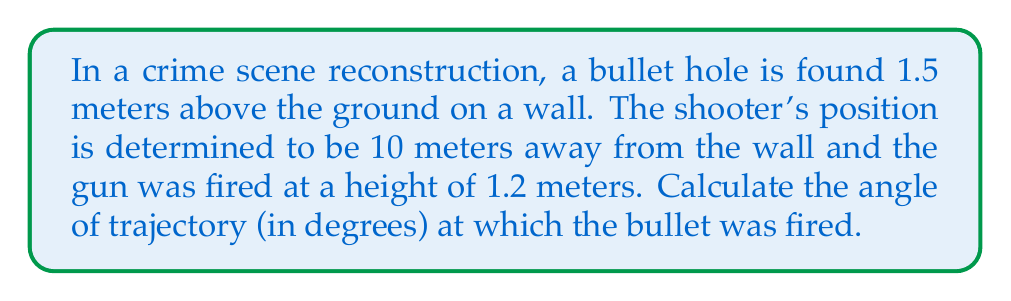What is the answer to this math problem? Let's approach this step-by-step:

1) First, we need to visualize the problem. We can think of this as a right triangle where:
   - The horizontal distance is 10 meters
   - The vertical distance is the difference between the bullet hole height and the gun height
   
2) Calculate the vertical distance:
   $1.5 \text{ m} - 1.2 \text{ m} = 0.3 \text{ m}$

3) Now we have a right triangle where:
   - The adjacent side (horizontal distance) is 10 meters
   - The opposite side (vertical distance) is 0.3 meters

4) To find the angle, we can use the tangent function:

   $$\tan(\theta) = \frac{\text{opposite}}{\text{adjacent}} = \frac{0.3}{10} = 0.03$$

5) To get the angle, we need to take the inverse tangent (arctan or $\tan^{-1}$):

   $$\theta = \tan^{-1}(0.03)$$

6) Using a calculator or computer:

   $$\theta \approx 1.7184^\circ$$

7) Round to two decimal places:

   $$\theta \approx 1.72^\circ$$

This angle represents the trajectory of the bullet from the horizontal.

[asy]
import geometry;

size(200);
draw((0,0)--(10,0)--(10,0.3)--cycle);
draw((0,0)--(10,0.3),arrow=Arrow(TeXHead));
label("10 m", (5,0), S);
label("0.3 m", (10,0.15), E);
label("θ", (0.5,0.05), NW);
dot((0,0));
dot((10,0.3));
[/asy]
Answer: $1.72^\circ$ 